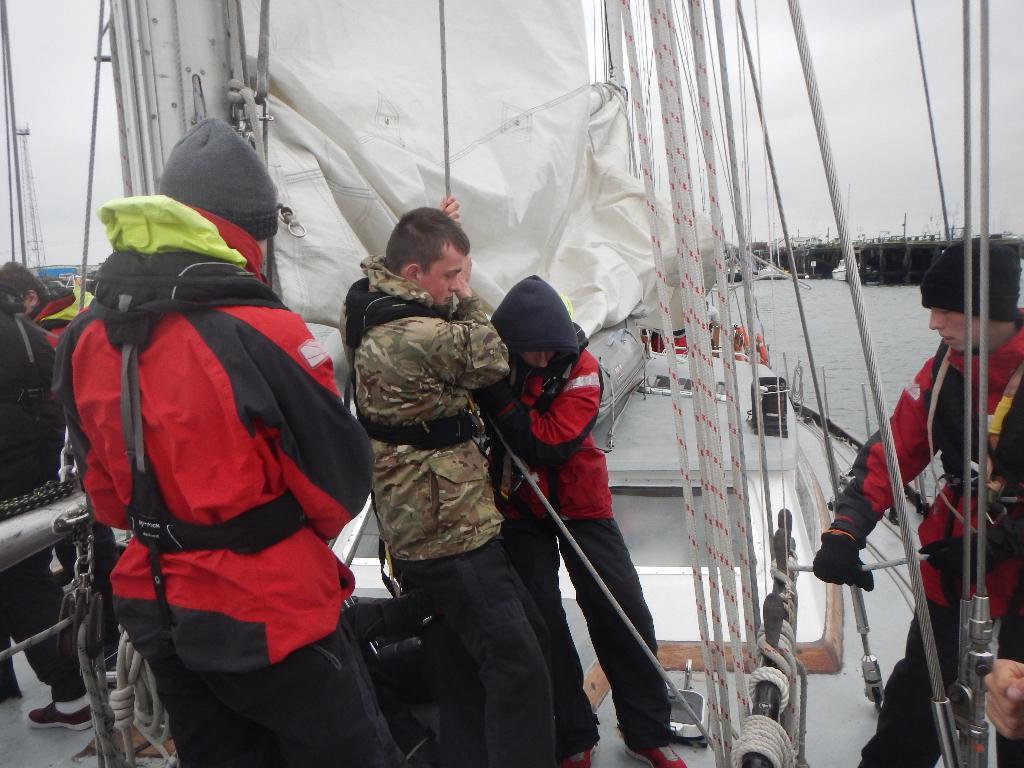Describe this image in one or two sentences. In this image I can see few persons are standing on the boat and holding ropes. I can see the white colored sheet and in the background I can see the water, few boats and the sky. 